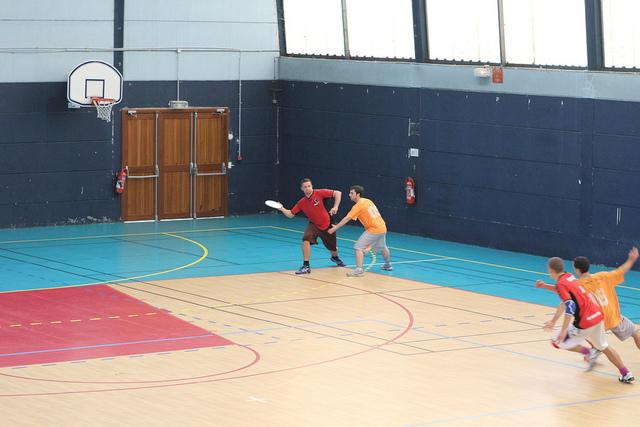What game is usually played on this court? basketball 